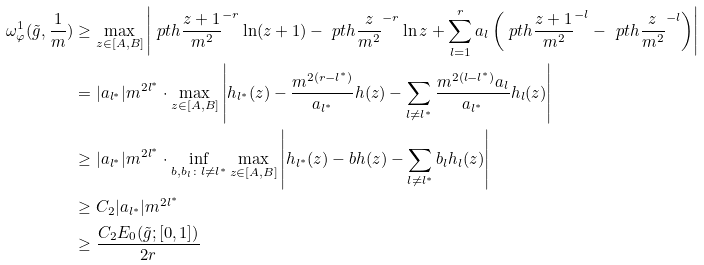Convert formula to latex. <formula><loc_0><loc_0><loc_500><loc_500>\omega _ { \varphi } ^ { 1 } ( \tilde { g } , \frac { 1 } { m } ) & \geq \max _ { z \in [ A , B ] } \left | \ p t h { \frac { z + 1 } { m ^ { 2 } } } ^ { - r } \ln ( z + 1 ) - \ p t h { \frac { z } { m ^ { 2 } } } ^ { - r } \ln z + \sum _ { l = 1 } ^ { r } a _ { l } \left ( \ p t h { \frac { z + 1 } { m ^ { 2 } } } ^ { - l } - \ p t h { \frac { z } { m ^ { 2 } } } ^ { - l } \right ) \right | \\ & = | a _ { l ^ { * } } | m ^ { 2 l ^ { * } } \cdot \max _ { z \in [ A , B ] } \left | h _ { l ^ { * } } ( z ) - \frac { m ^ { 2 ( r - l ^ { * } ) } } { a _ { l ^ { * } } } h ( z ) - \sum _ { l \neq l ^ { * } } \frac { m ^ { 2 ( l - l ^ { * } ) } a _ { l } } { a _ { l ^ { * } } } h _ { l } ( z ) \right | \\ & \geq | a _ { l ^ { * } } | m ^ { 2 l ^ { * } } \cdot \inf _ { b , b _ { l } \colon l \neq l ^ { * } } \max _ { z \in [ A , B ] } \left | h _ { l ^ { * } } ( z ) - b h ( z ) - \sum _ { l \neq l ^ { * } } b _ { l } h _ { l } ( z ) \right | \\ & \geq C _ { 2 } | a _ { l ^ { * } } | m ^ { 2 l ^ { * } } \\ & \geq \frac { C _ { 2 } E _ { 0 } ( \tilde { g } ; [ 0 , 1 ] ) } { 2 r }</formula> 